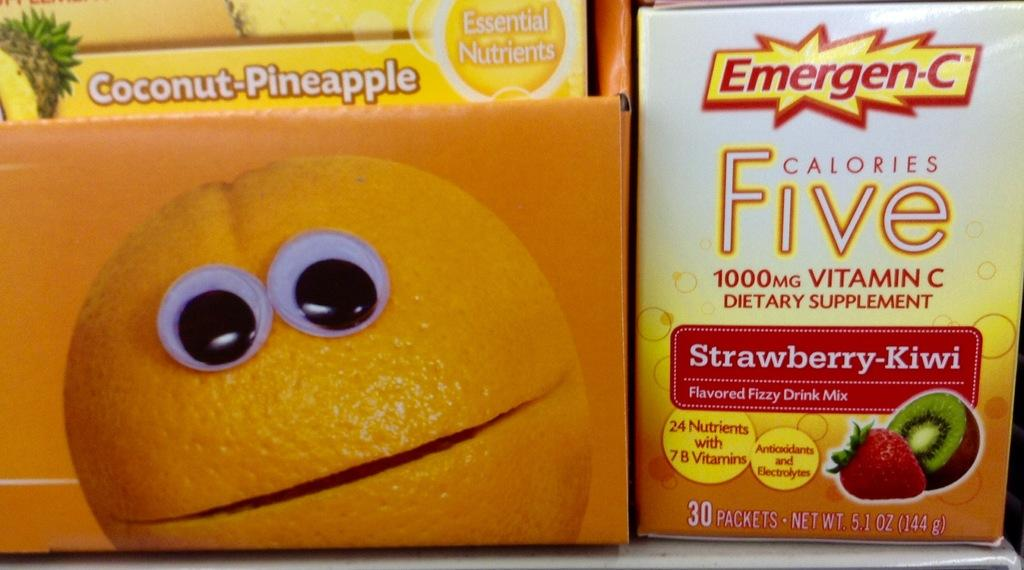What can be seen in the foreground of the image? There are drink packets in the foreground of the image. Can you describe the drink on the right side of the image? There is a strawberry drink on the right side of the image. What type of jewel is being used to stir the strawberry drink in the image? There is no jewel present in the image, and the drink does not require stirring. 